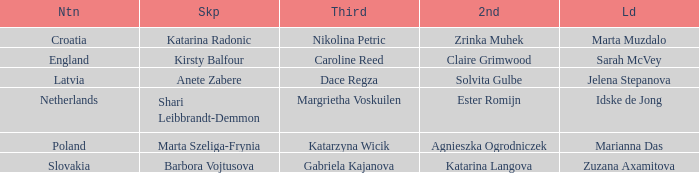Who is the Second with Nikolina Petric as Third? Zrinka Muhek. 